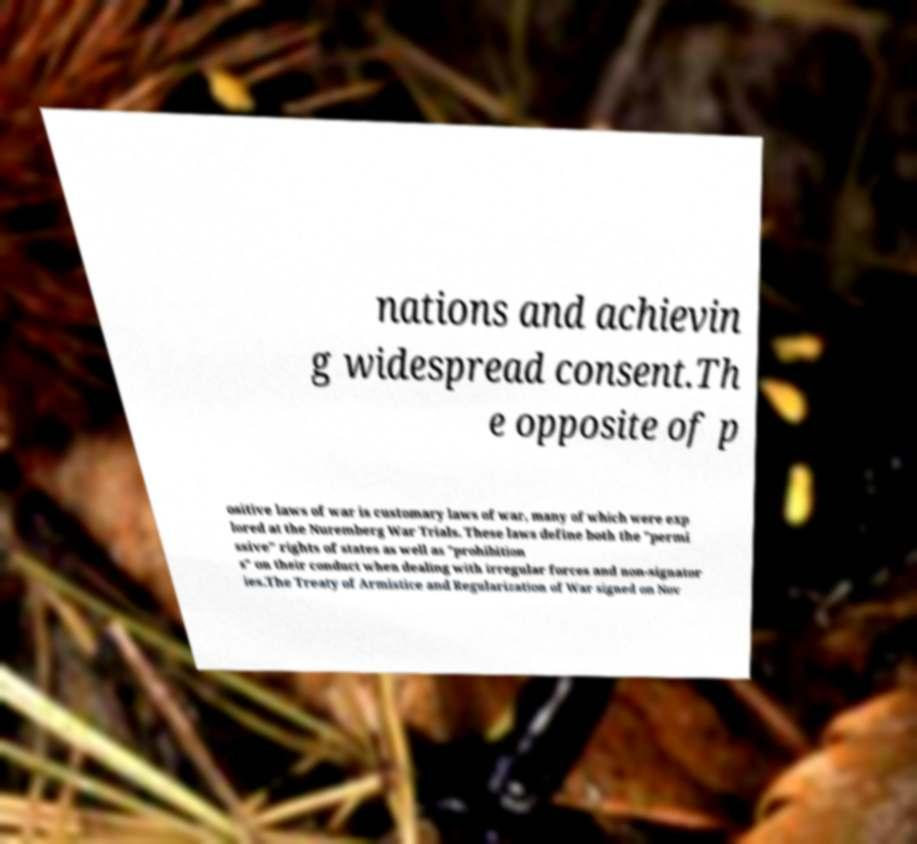Could you extract and type out the text from this image? nations and achievin g widespread consent.Th e opposite of p ositive laws of war is customary laws of war, many of which were exp lored at the Nuremberg War Trials. These laws define both the "permi ssive" rights of states as well as "prohibition s" on their conduct when dealing with irregular forces and non-signator ies.The Treaty of Armistice and Regularization of War signed on Nov 